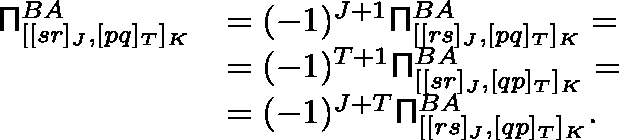<formula> <loc_0><loc_0><loc_500><loc_500>\begin{array} { r l } { \Pi _ { [ [ s r ] _ { J } , [ p q ] _ { T } ] _ { K } } ^ { B A } } & { = ( - 1 ) ^ { J + 1 } \Pi _ { [ [ r s ] _ { J } , [ p q ] _ { T } ] _ { K } } ^ { B A } = } \\ & { = ( - 1 ) ^ { T + 1 } \Pi _ { [ [ s r ] _ { J } , [ q p ] _ { T } ] _ { K } } ^ { B A } = } \\ & { = ( - 1 ) ^ { J + T } \Pi _ { [ [ r s ] _ { J } , [ q p ] _ { T } ] _ { K } } ^ { B A } . } \end{array}</formula> 